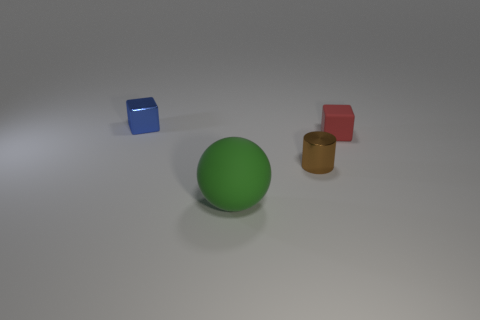The tiny object that is on the left side of the small red thing and in front of the small shiny block is what color?
Your response must be concise. Brown. What number of objects are tiny metallic objects right of the small blue block or big brown balls?
Make the answer very short. 1. What number of other objects are there of the same color as the tiny metal cylinder?
Make the answer very short. 0. Is the number of brown cylinders behind the brown metal cylinder the same as the number of large yellow rubber spheres?
Your response must be concise. Yes. There is a metallic object that is in front of the small cube left of the small brown cylinder; what number of tiny red matte blocks are behind it?
Your answer should be compact. 1. Is there any other thing that has the same size as the green rubber thing?
Offer a very short reply. No. Is the size of the green ball the same as the matte object that is behind the small brown object?
Ensure brevity in your answer.  No. What number of small green cylinders are there?
Your response must be concise. 0. Do the thing that is on the left side of the big green rubber sphere and the rubber thing that is behind the large green matte thing have the same size?
Provide a short and direct response. Yes. What is the color of the other tiny thing that is the same shape as the red matte thing?
Your response must be concise. Blue. 